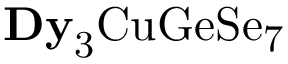<formula> <loc_0><loc_0><loc_500><loc_500>{ D y } _ { 3 } C u G e S e _ { 7 }</formula> 